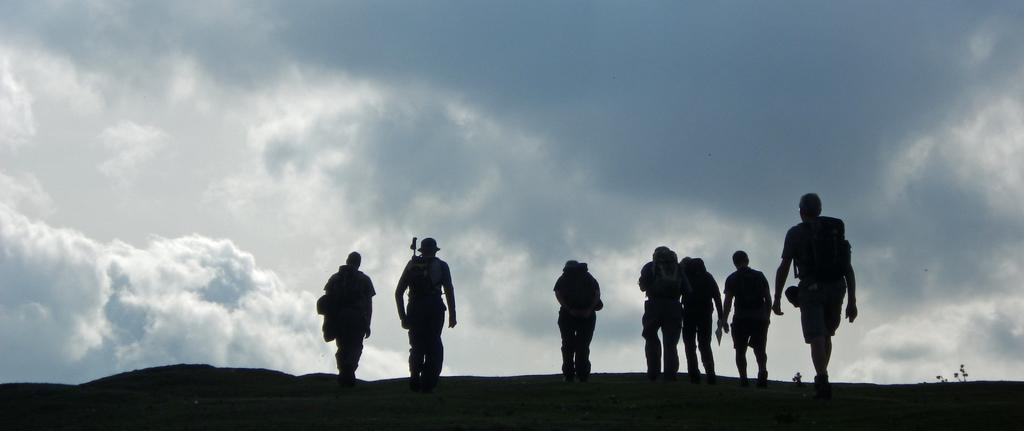How many people are in the image? There is a group of people in the image, but the exact number cannot be determined from the provided facts. What is visible in the background of the image? The sky is visible in the background of the image. Can you describe the sky in the image? The sky appears to be cloudy in the image. Where is the basin located in the image? There is no basin present in the image. What type of fan is being used by the people in the image? There is no fan visible in the image. 